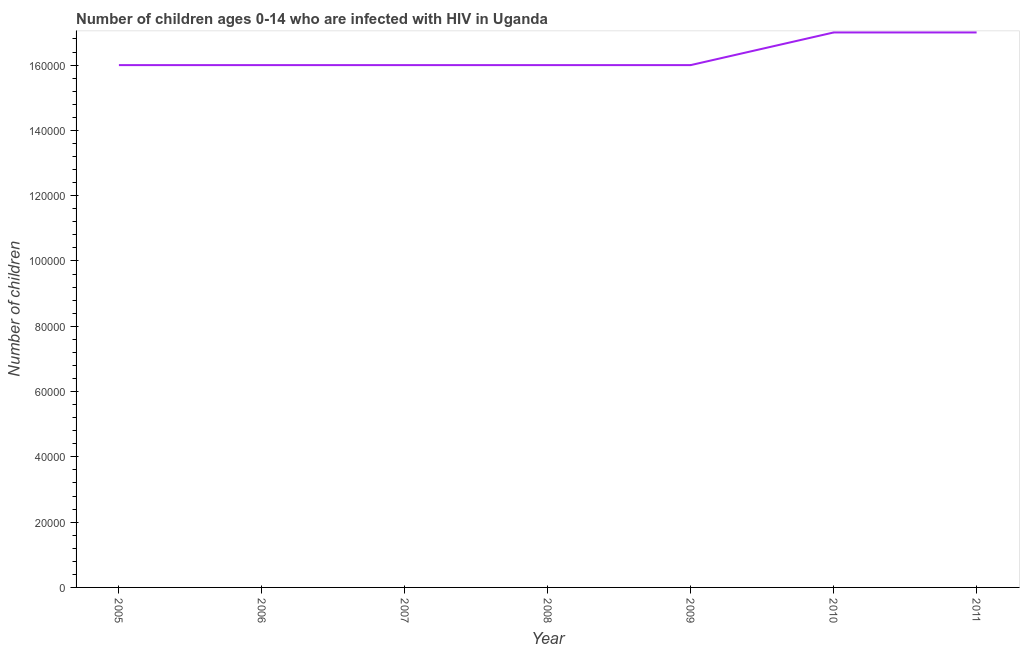What is the number of children living with hiv in 2007?
Give a very brief answer. 1.60e+05. Across all years, what is the maximum number of children living with hiv?
Keep it short and to the point. 1.70e+05. Across all years, what is the minimum number of children living with hiv?
Ensure brevity in your answer.  1.60e+05. What is the sum of the number of children living with hiv?
Your answer should be very brief. 1.14e+06. What is the average number of children living with hiv per year?
Your answer should be compact. 1.63e+05. What is the median number of children living with hiv?
Your response must be concise. 1.60e+05. In how many years, is the number of children living with hiv greater than 112000 ?
Offer a terse response. 7. Do a majority of the years between 2010 and 2007 (inclusive) have number of children living with hiv greater than 76000 ?
Keep it short and to the point. Yes. What is the ratio of the number of children living with hiv in 2005 to that in 2009?
Your answer should be very brief. 1. Is the difference between the number of children living with hiv in 2009 and 2010 greater than the difference between any two years?
Keep it short and to the point. Yes. What is the difference between the highest and the second highest number of children living with hiv?
Your response must be concise. 0. What is the difference between the highest and the lowest number of children living with hiv?
Ensure brevity in your answer.  10000. How many lines are there?
Ensure brevity in your answer.  1. Are the values on the major ticks of Y-axis written in scientific E-notation?
Your answer should be compact. No. Does the graph contain grids?
Offer a very short reply. No. What is the title of the graph?
Keep it short and to the point. Number of children ages 0-14 who are infected with HIV in Uganda. What is the label or title of the Y-axis?
Offer a terse response. Number of children. What is the Number of children in 2005?
Your answer should be very brief. 1.60e+05. What is the Number of children in 2007?
Make the answer very short. 1.60e+05. What is the Number of children in 2009?
Your answer should be very brief. 1.60e+05. What is the difference between the Number of children in 2005 and 2007?
Your response must be concise. 0. What is the difference between the Number of children in 2005 and 2008?
Your answer should be compact. 0. What is the difference between the Number of children in 2005 and 2010?
Your answer should be compact. -10000. What is the difference between the Number of children in 2005 and 2011?
Your response must be concise. -10000. What is the difference between the Number of children in 2006 and 2007?
Provide a succinct answer. 0. What is the difference between the Number of children in 2006 and 2008?
Ensure brevity in your answer.  0. What is the difference between the Number of children in 2007 and 2011?
Make the answer very short. -10000. What is the difference between the Number of children in 2008 and 2009?
Your response must be concise. 0. What is the difference between the Number of children in 2008 and 2010?
Your response must be concise. -10000. What is the difference between the Number of children in 2009 and 2011?
Offer a very short reply. -10000. What is the difference between the Number of children in 2010 and 2011?
Provide a short and direct response. 0. What is the ratio of the Number of children in 2005 to that in 2008?
Offer a very short reply. 1. What is the ratio of the Number of children in 2005 to that in 2010?
Provide a succinct answer. 0.94. What is the ratio of the Number of children in 2005 to that in 2011?
Offer a terse response. 0.94. What is the ratio of the Number of children in 2006 to that in 2007?
Make the answer very short. 1. What is the ratio of the Number of children in 2006 to that in 2008?
Offer a terse response. 1. What is the ratio of the Number of children in 2006 to that in 2009?
Give a very brief answer. 1. What is the ratio of the Number of children in 2006 to that in 2010?
Your response must be concise. 0.94. What is the ratio of the Number of children in 2006 to that in 2011?
Ensure brevity in your answer.  0.94. What is the ratio of the Number of children in 2007 to that in 2009?
Offer a terse response. 1. What is the ratio of the Number of children in 2007 to that in 2010?
Give a very brief answer. 0.94. What is the ratio of the Number of children in 2007 to that in 2011?
Your answer should be compact. 0.94. What is the ratio of the Number of children in 2008 to that in 2009?
Make the answer very short. 1. What is the ratio of the Number of children in 2008 to that in 2010?
Offer a very short reply. 0.94. What is the ratio of the Number of children in 2008 to that in 2011?
Your answer should be very brief. 0.94. What is the ratio of the Number of children in 2009 to that in 2010?
Your answer should be very brief. 0.94. What is the ratio of the Number of children in 2009 to that in 2011?
Offer a very short reply. 0.94. What is the ratio of the Number of children in 2010 to that in 2011?
Provide a succinct answer. 1. 